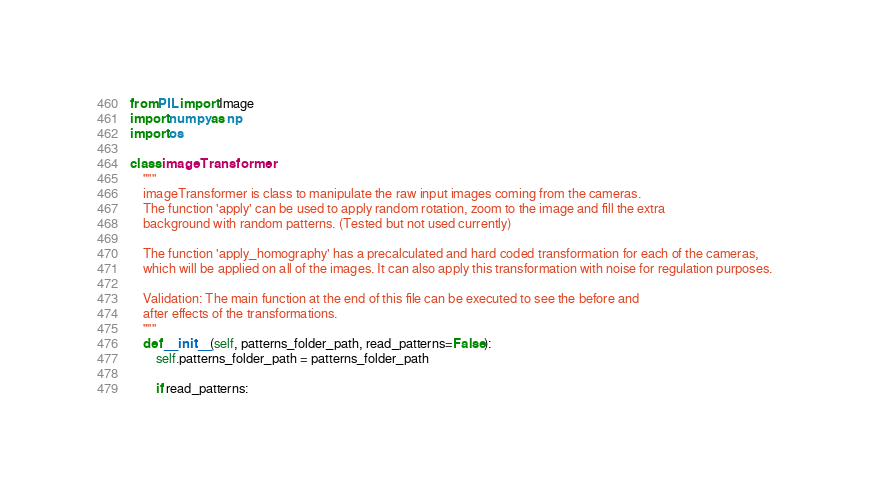Convert code to text. <code><loc_0><loc_0><loc_500><loc_500><_Python_>from PIL import Image
import numpy as np
import os

class imageTransformer:
    """
    imageTransformer is class to manipulate the raw input images coming from the cameras.
    The function 'apply' can be used to apply random rotation, zoom to the image and fill the extra 
    background with random patterns. (Tested but not used currently)

    The function 'apply_homography' has a precalculated and hard coded transformation for each of the cameras,
    which will be applied on all of the images. It can also apply this transformation with noise for regulation purposes.

    Validation: The main function at the end of this file can be executed to see the before and
    after effects of the transformations.
    """
    def __init__(self, patterns_folder_path, read_patterns=False):
        self.patterns_folder_path = patterns_folder_path
        
        if read_patterns:</code> 